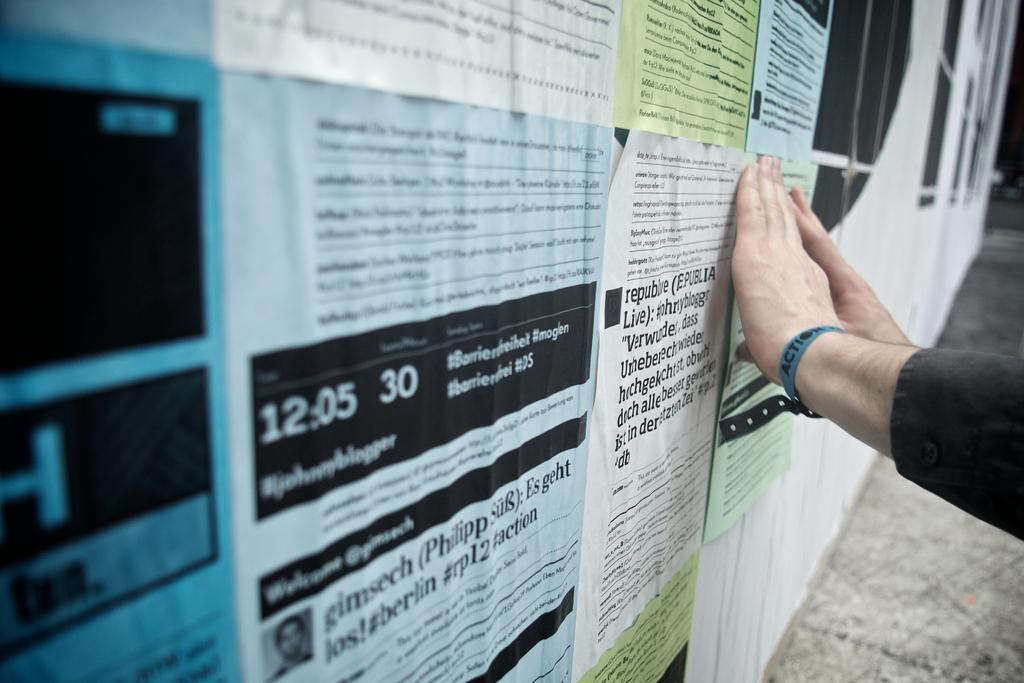<image>
Give a short and clear explanation of the subsequent image. A bulletin board and there is a paper that says 12:05 30. 